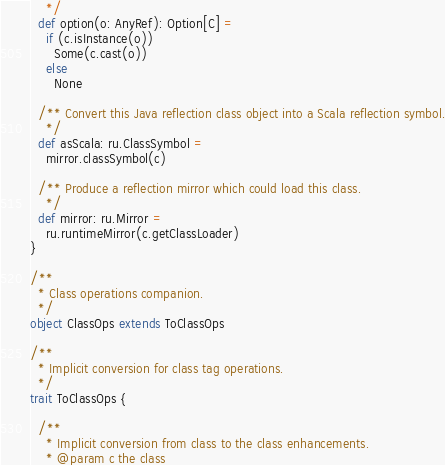<code> <loc_0><loc_0><loc_500><loc_500><_Scala_>    */
  def option(o: AnyRef): Option[C] =
    if (c.isInstance(o))
      Some(c.cast(o))
    else
      None

  /** Convert this Java reflection class object into a Scala reflection symbol.
    */
  def asScala: ru.ClassSymbol =
    mirror.classSymbol(c)

  /** Produce a reflection mirror which could load this class.
    */
  def mirror: ru.Mirror =
    ru.runtimeMirror(c.getClassLoader)
}

/**
  * Class operations companion.
  */
object ClassOps extends ToClassOps

/**
  * Implicit conversion for class tag operations.
  */
trait ToClassOps {

  /**
    * Implicit conversion from class to the class enhancements.
    * @param c the class</code> 